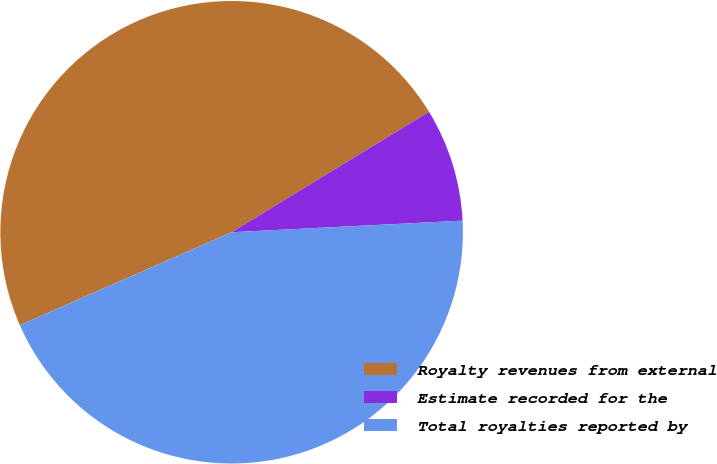Convert chart to OTSL. <chart><loc_0><loc_0><loc_500><loc_500><pie_chart><fcel>Royalty revenues from external<fcel>Estimate recorded for the<fcel>Total royalties reported by<nl><fcel>47.86%<fcel>7.92%<fcel>44.22%<nl></chart> 